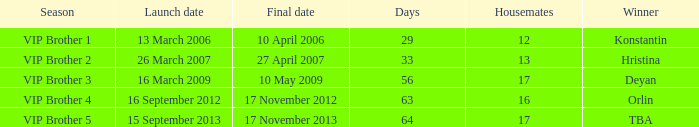Could you help me parse every detail presented in this table? {'header': ['Season', 'Launch date', 'Final date', 'Days', 'Housemates', 'Winner'], 'rows': [['VIP Brother 1', '13 March 2006', '10 April 2006', '29', '12', 'Konstantin'], ['VIP Brother 2', '26 March 2007', '27 April 2007', '33', '13', 'Hristina'], ['VIP Brother 3', '16 March 2009', '10 May 2009', '56', '17', 'Deyan'], ['VIP Brother 4', '16 September 2012', '17 November 2012', '63', '16', 'Orlin'], ['VIP Brother 5', '15 September 2013', '17 November 2013', '64', '17', 'TBA']]} When was the last day that had 16 housemates? 17 November 2012. 